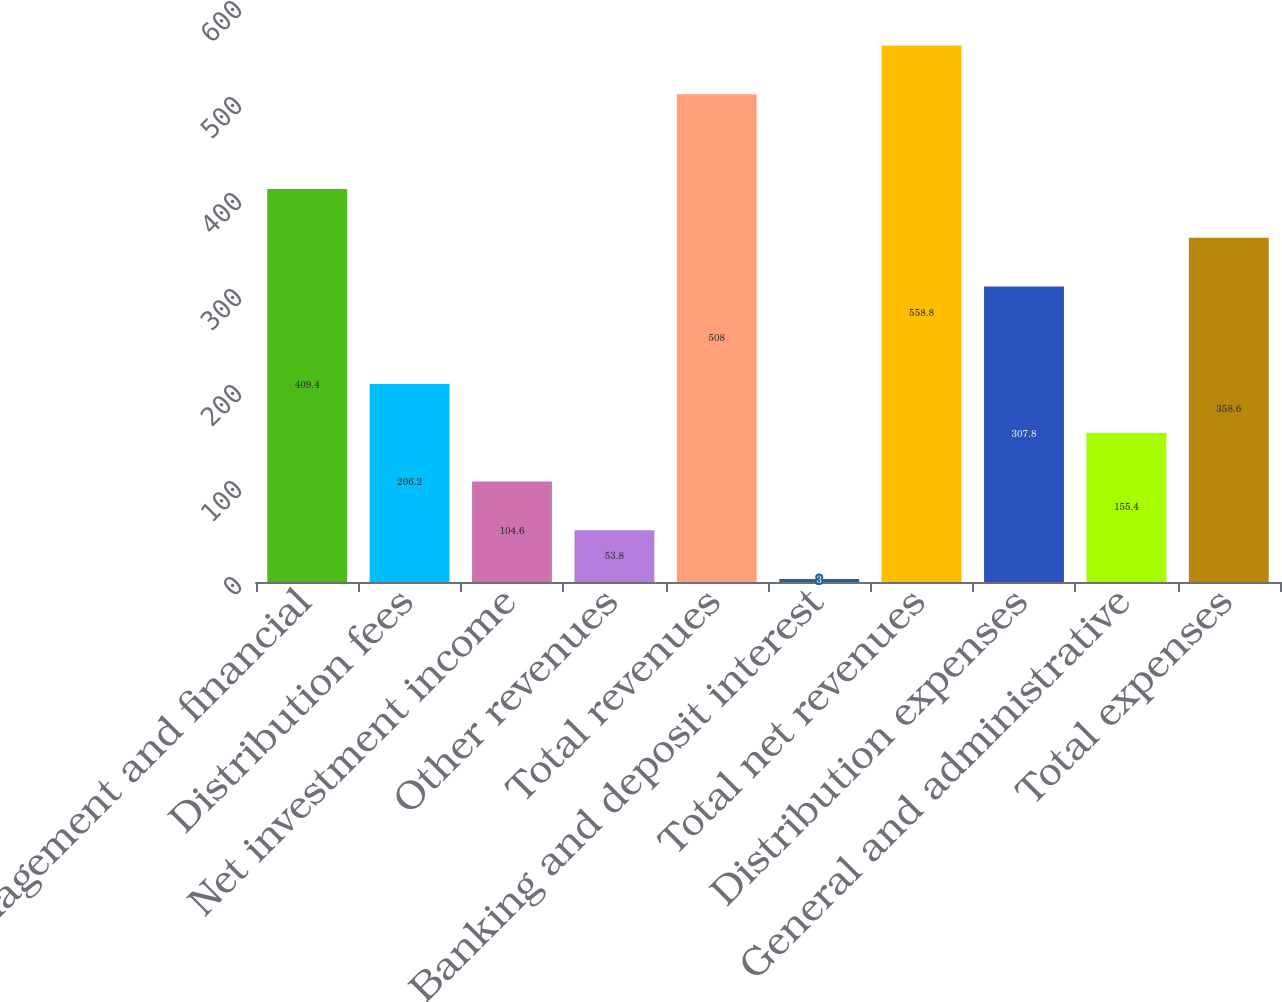<chart> <loc_0><loc_0><loc_500><loc_500><bar_chart><fcel>Management and financial<fcel>Distribution fees<fcel>Net investment income<fcel>Other revenues<fcel>Total revenues<fcel>Banking and deposit interest<fcel>Total net revenues<fcel>Distribution expenses<fcel>General and administrative<fcel>Total expenses<nl><fcel>409.4<fcel>206.2<fcel>104.6<fcel>53.8<fcel>508<fcel>3<fcel>558.8<fcel>307.8<fcel>155.4<fcel>358.6<nl></chart> 